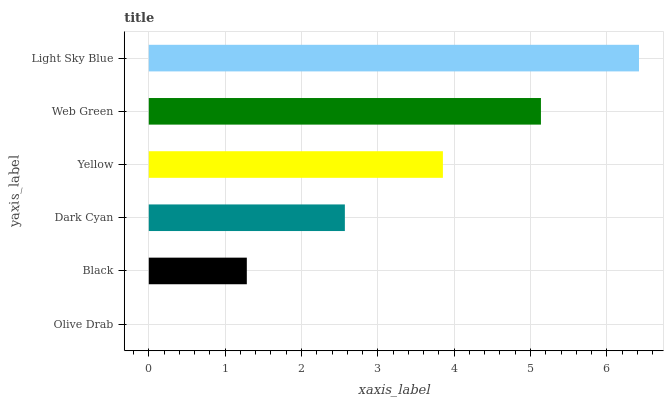Is Olive Drab the minimum?
Answer yes or no. Yes. Is Light Sky Blue the maximum?
Answer yes or no. Yes. Is Black the minimum?
Answer yes or no. No. Is Black the maximum?
Answer yes or no. No. Is Black greater than Olive Drab?
Answer yes or no. Yes. Is Olive Drab less than Black?
Answer yes or no. Yes. Is Olive Drab greater than Black?
Answer yes or no. No. Is Black less than Olive Drab?
Answer yes or no. No. Is Yellow the high median?
Answer yes or no. Yes. Is Dark Cyan the low median?
Answer yes or no. Yes. Is Black the high median?
Answer yes or no. No. Is Olive Drab the low median?
Answer yes or no. No. 